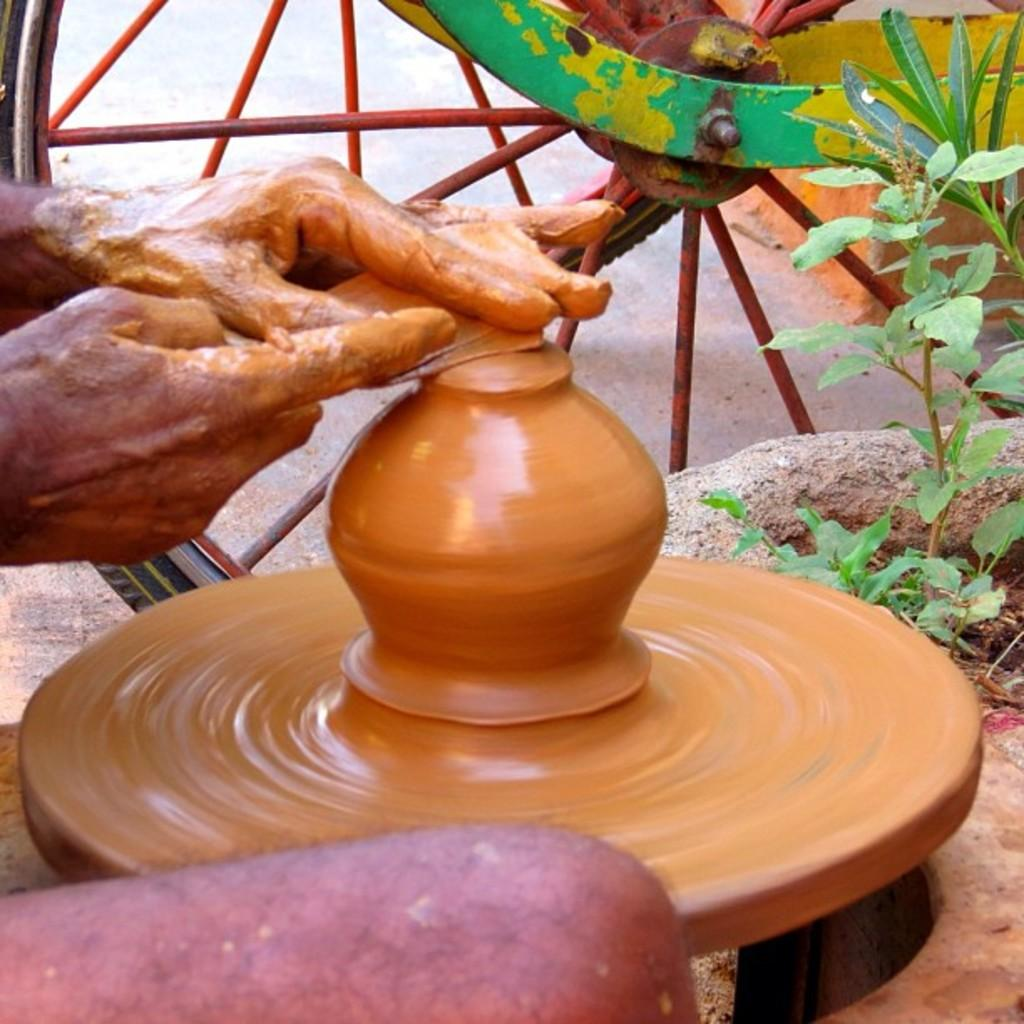What is the person in the image doing? The person in the image is making a pot. What can be seen on the right side of the image? There is a plant on the right side of the image. What object is visible in the background of the image? There is a wheel visible in the background of the image. Is the woman in the image wearing a chain around her neck? There is no woman present in the image, and even if there were, the facts provided do not mention any jewelry or accessories. 